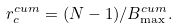<formula> <loc_0><loc_0><loc_500><loc_500>r _ { c } ^ { c u m } = ( N - 1 ) / B _ { \max } ^ { c u m } .</formula> 